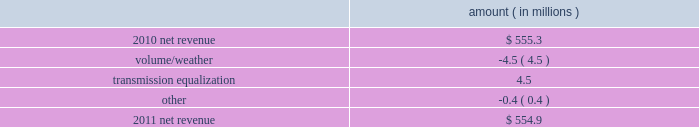Entergy mississippi , inc .
Management 2019s financial discussion and analysis plan to spin off the utility 2019s transmission business see the 201cplan to spin off the utility 2019s transmission business 201d section of entergy corporation and subsidiaries management 2019s financial discussion and analysis for a discussion of this matter , including the planned retirement of debt and preferred securities .
Results of operations net income 2011 compared to 2010 net income increased $ 23.4 million primarily due to a lower effective income tax rate .
2010 compared to 2009 net income increased $ 6.0 million primarily due to higher net revenue and higher other income , partially offset by higher taxes other than income taxes , higher depreciation and amortization expenses , and higher interest expense .
Net revenue 2011 compared to 2010 net revenue consists of operating revenues net of : 1 ) fuel , fuel-related expenses , and gas purchased for resale , 2 ) purchased power expenses , and 3 ) other regulatory charges ( credits ) .
Following is an analysis of the change in net revenue comparing 2011 to 2010 .
Amount ( in millions ) .
The volume/weather variance is primarily due to a decrease of 97 gwh in weather-adjusted usage in the residential and commercial sectors and a decrease in sales volume in the unbilled sales period .
The transmission equalization variance is primarily due to the addition in 2011 of transmission investments that are subject to equalization .
Gross operating revenues and fuel and purchased power expenses gross operating revenues increased primarily due to an increase of $ 57.5 million in gross wholesale revenues due to an increase in sales to affiliated customers , partially offset by a decrease of $ 26.9 million in power management rider revenue .
Fuel and purchased power expenses increased primarily due to an increase in deferred fuel expense as a result of higher fuel revenues due to higher fuel rates , partially offset by a decrease in the average market prices of natural gas and purchased power. .
What was the ratio of the increase in the net income in 2011 compared to 2010? 
Computations: (23.4 / 6)
Answer: 3.9. 